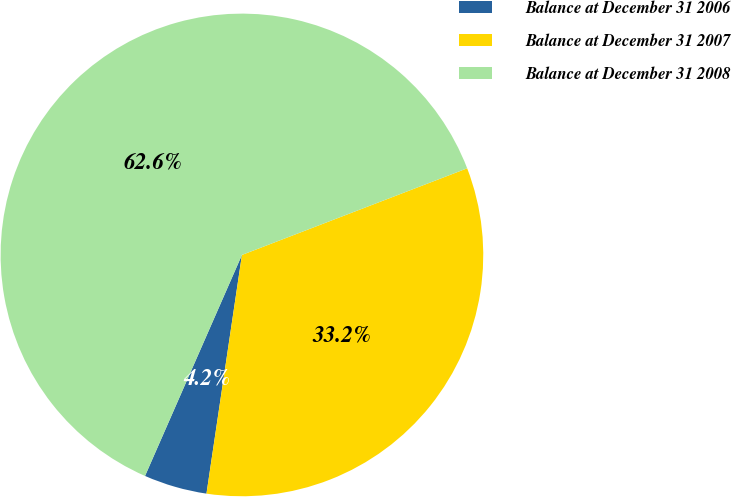Convert chart. <chart><loc_0><loc_0><loc_500><loc_500><pie_chart><fcel>Balance at December 31 2006<fcel>Balance at December 31 2007<fcel>Balance at December 31 2008<nl><fcel>4.23%<fcel>33.19%<fcel>62.58%<nl></chart> 